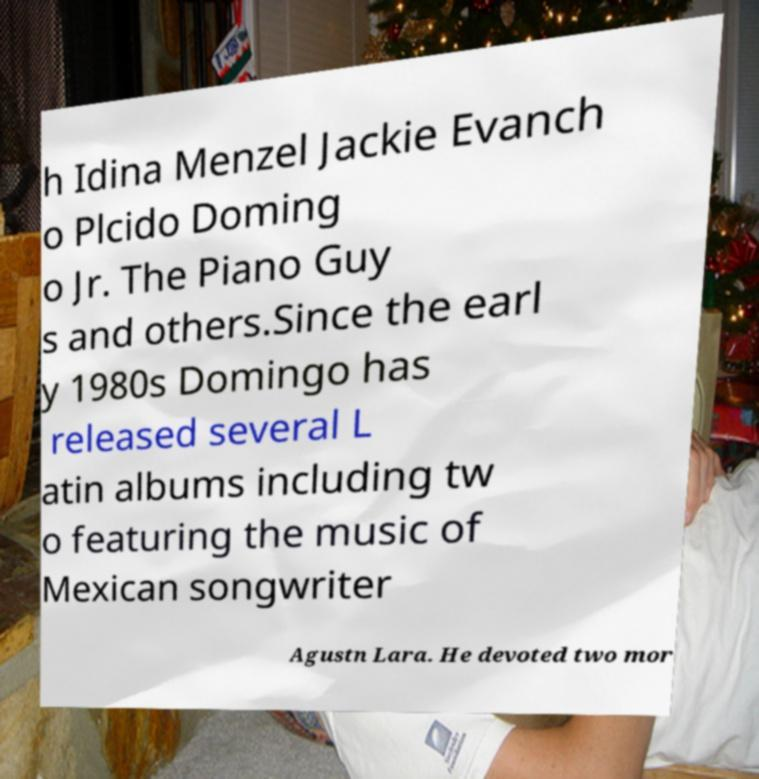For documentation purposes, I need the text within this image transcribed. Could you provide that? h Idina Menzel Jackie Evanch o Plcido Doming o Jr. The Piano Guy s and others.Since the earl y 1980s Domingo has released several L atin albums including tw o featuring the music of Mexican songwriter Agustn Lara. He devoted two mor 